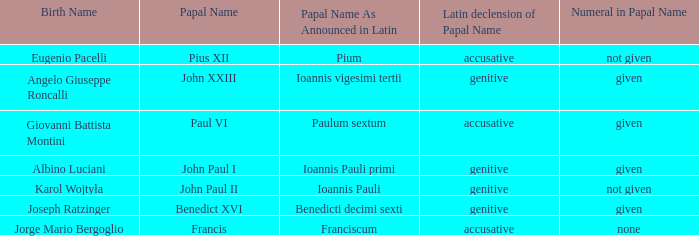Can you give me this table as a dict? {'header': ['Birth Name', 'Papal Name', 'Papal Name As Announced in Latin', 'Latin declension of Papal Name', 'Numeral in Papal Name'], 'rows': [['Eugenio Pacelli', 'Pius XII', 'Pium', 'accusative', 'not given'], ['Angelo Giuseppe Roncalli', 'John XXIII', 'Ioannis vigesimi tertii', 'genitive', 'given'], ['Giovanni Battista Montini', 'Paul VI', 'Paulum sextum', 'accusative', 'given'], ['Albino Luciani', 'John Paul I', 'Ioannis Pauli primi', 'genitive', 'given'], ['Karol Wojtyła', 'John Paul II', 'Ioannis Pauli', 'genitive', 'not given'], ['Joseph Ratzinger', 'Benedict XVI', 'Benedicti decimi sexti', 'genitive', 'given'], ['Jorge Mario Bergoglio', 'Francis', 'Franciscum', 'accusative', 'none']]} For the pope born Eugenio Pacelli, what is the declension of his papal name? Accusative. 